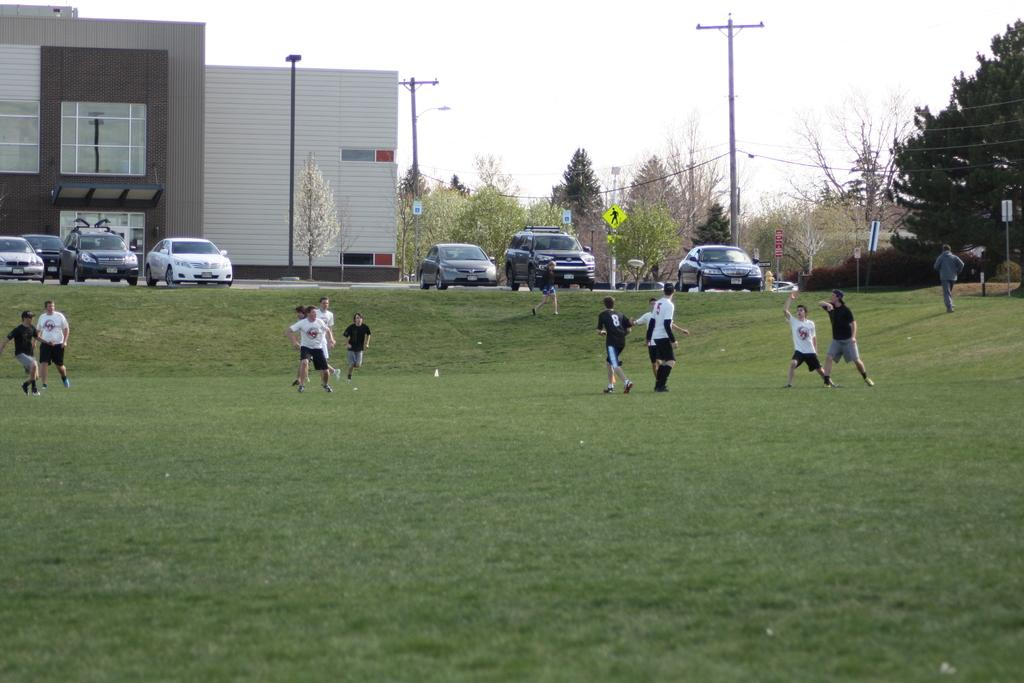What are the people in the image doing? The people in the image are playing on the grass ground. What can be seen in the background of the image? In the background, there are vehicles, buildings, trees, poles, and sign boards. Can you describe the setting where the people are playing? The people are playing in an area with grass, and there are various structures and objects visible in the background. How many frogs can be seen in the scene? There are no frogs present in the image. What type of prison is depicted in the background? There is no prison depicted in the image; it features people playing on the grass ground and various structures and objects in the background. 